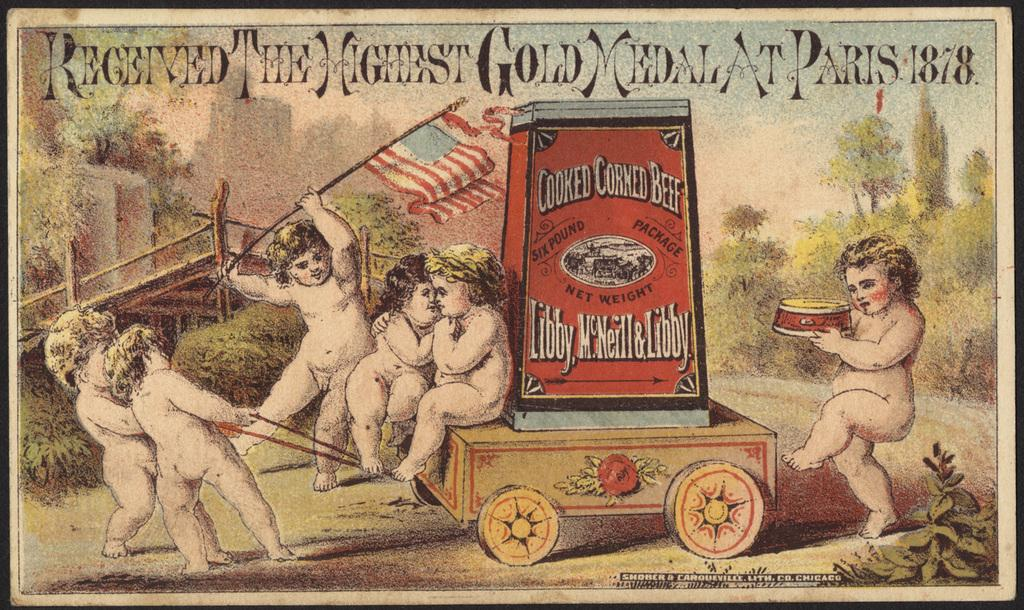<image>
Summarize the visual content of the image. A poster includes cherubs pilling a wagon with a can of corned beef in it. 